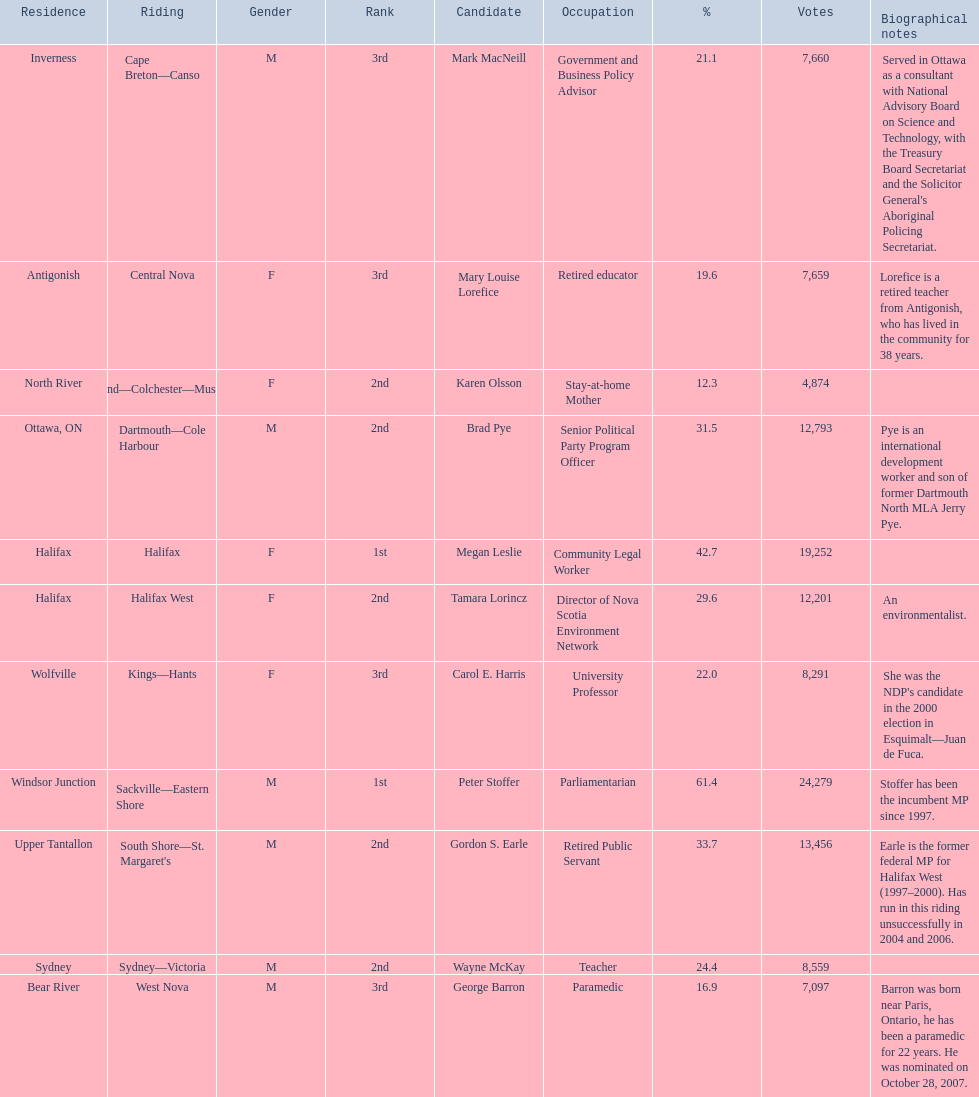Who were the new democratic party candidates, 2008? Mark MacNeill, Mary Louise Lorefice, Karen Olsson, Brad Pye, Megan Leslie, Tamara Lorincz, Carol E. Harris, Peter Stoffer, Gordon S. Earle, Wayne McKay, George Barron. Who had the 2nd highest number of votes? Megan Leslie, Peter Stoffer. How many votes did she receive? 19,252. 